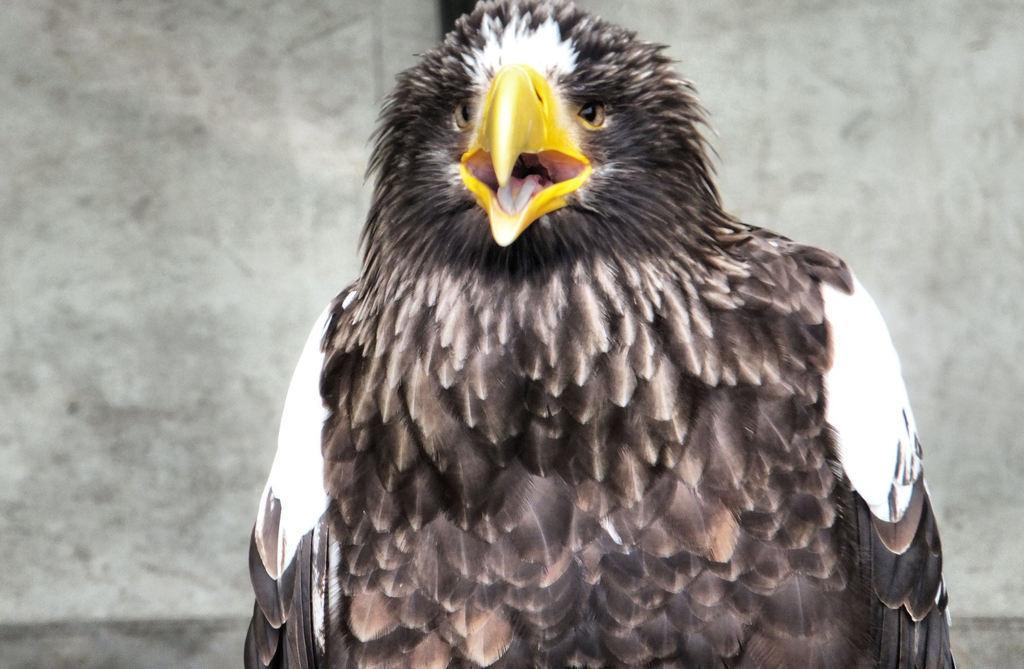How would you summarize this image in a sentence or two? In the center of the image we can see a bird, which is in a multi color. In the background there is a wall. 